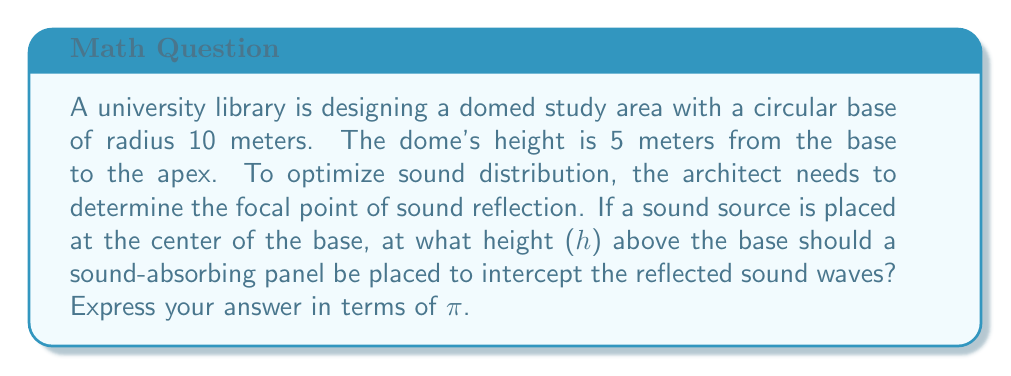What is the answer to this math problem? Let's approach this step-by-step:

1) The dome forms a section of a sphere. We need to find the radius (R) of this sphere.

2) Let's set up a coordinate system with the origin at the center of the base circle. The equation of the sphere is:

   $$x^2 + y^2 + (z-R)^2 = R^2$$

3) We know that the point (10, 0, 5) lies on this sphere (edge of the base and top of the dome). Substituting:

   $$10^2 + 0^2 + (5-R)^2 = R^2$$

4) Simplify:

   $$100 + (5-R)^2 = R^2$$

5) Expand:

   $$100 + 25 - 10R + R^2 = R^2$$

6) Simplify:

   $$125 - 10R = 0$$

7) Solve for R:

   $$R = 12.5$$

8) The focal point of a spherical mirror is halfway between the center of the sphere and the surface. The center is 12.5 meters above the base, so the focal point is:

   $$h = 12.5 - \frac{12.5}{2} = 6.25$$

9) We can express this in terms of π:

   $$h = \frac{25\pi}{4\pi} = \frac{25}{4\pi}$$ meters
Answer: $\frac{25}{4\pi}$ meters 